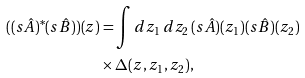Convert formula to latex. <formula><loc_0><loc_0><loc_500><loc_500>( ( s \hat { A } ) ^ { * } ( s \hat { B } ) ) ( z ) & = \int d z _ { 1 } \, d z _ { 2 } \, ( s \hat { A } ) ( z _ { 1 } ) ( s \hat { B } ) ( z _ { 2 } ) \\ & \times \Delta ( z , z _ { 1 } , z _ { 2 } ) ,</formula> 